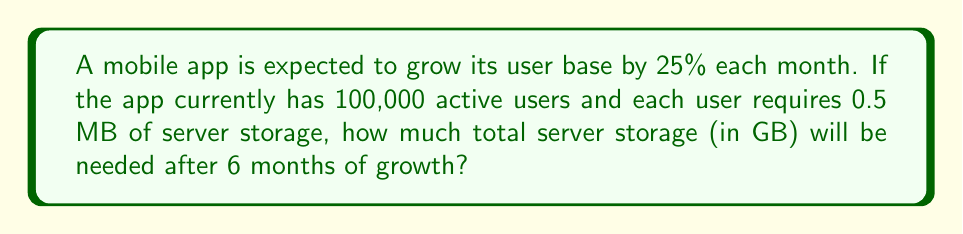Provide a solution to this math problem. Let's approach this step-by-step:

1) First, we need to calculate the number of users after 6 months of 25% monthly growth.
   Let's use the compound growth formula:
   $$A = P(1 + r)^n$$
   Where:
   $A$ = Final amount
   $P$ = Initial amount (100,000 users)
   $r$ = Monthly growth rate (25% = 0.25)
   $n$ = Number of months (6)

2) Plugging in the values:
   $$A = 100,000(1 + 0.25)^6 = 100,000(1.25)^6 = 381,469.73$$

3) Rounding up to the nearest whole number: 381,470 users

4) Now, we need to calculate the storage needed:
   Each user requires 0.5 MB of storage
   Total storage = 381,470 * 0.5 MB = 190,735 MB

5) Convert MB to GB:
   1 GB = 1024 MB
   190,735 MB / 1024 = 186.26 GB

6) Rounding up to ensure sufficient capacity: 187 GB
Answer: 187 GB 